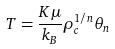Convert formula to latex. <formula><loc_0><loc_0><loc_500><loc_500>T = \frac { K \mu } { k _ { B } } \rho _ { c } ^ { 1 / n } \theta _ { n }</formula> 